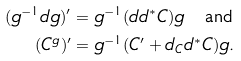<formula> <loc_0><loc_0><loc_500><loc_500>( g ^ { - 1 } d g ) ^ { \prime } & = g ^ { - 1 } ( d d ^ { * } C ) g \quad \text {and} \\ ( C ^ { g } ) ^ { \prime } & = g ^ { - 1 } ( C ^ { \prime } + d _ { C } d ^ { * } C ) g .</formula> 